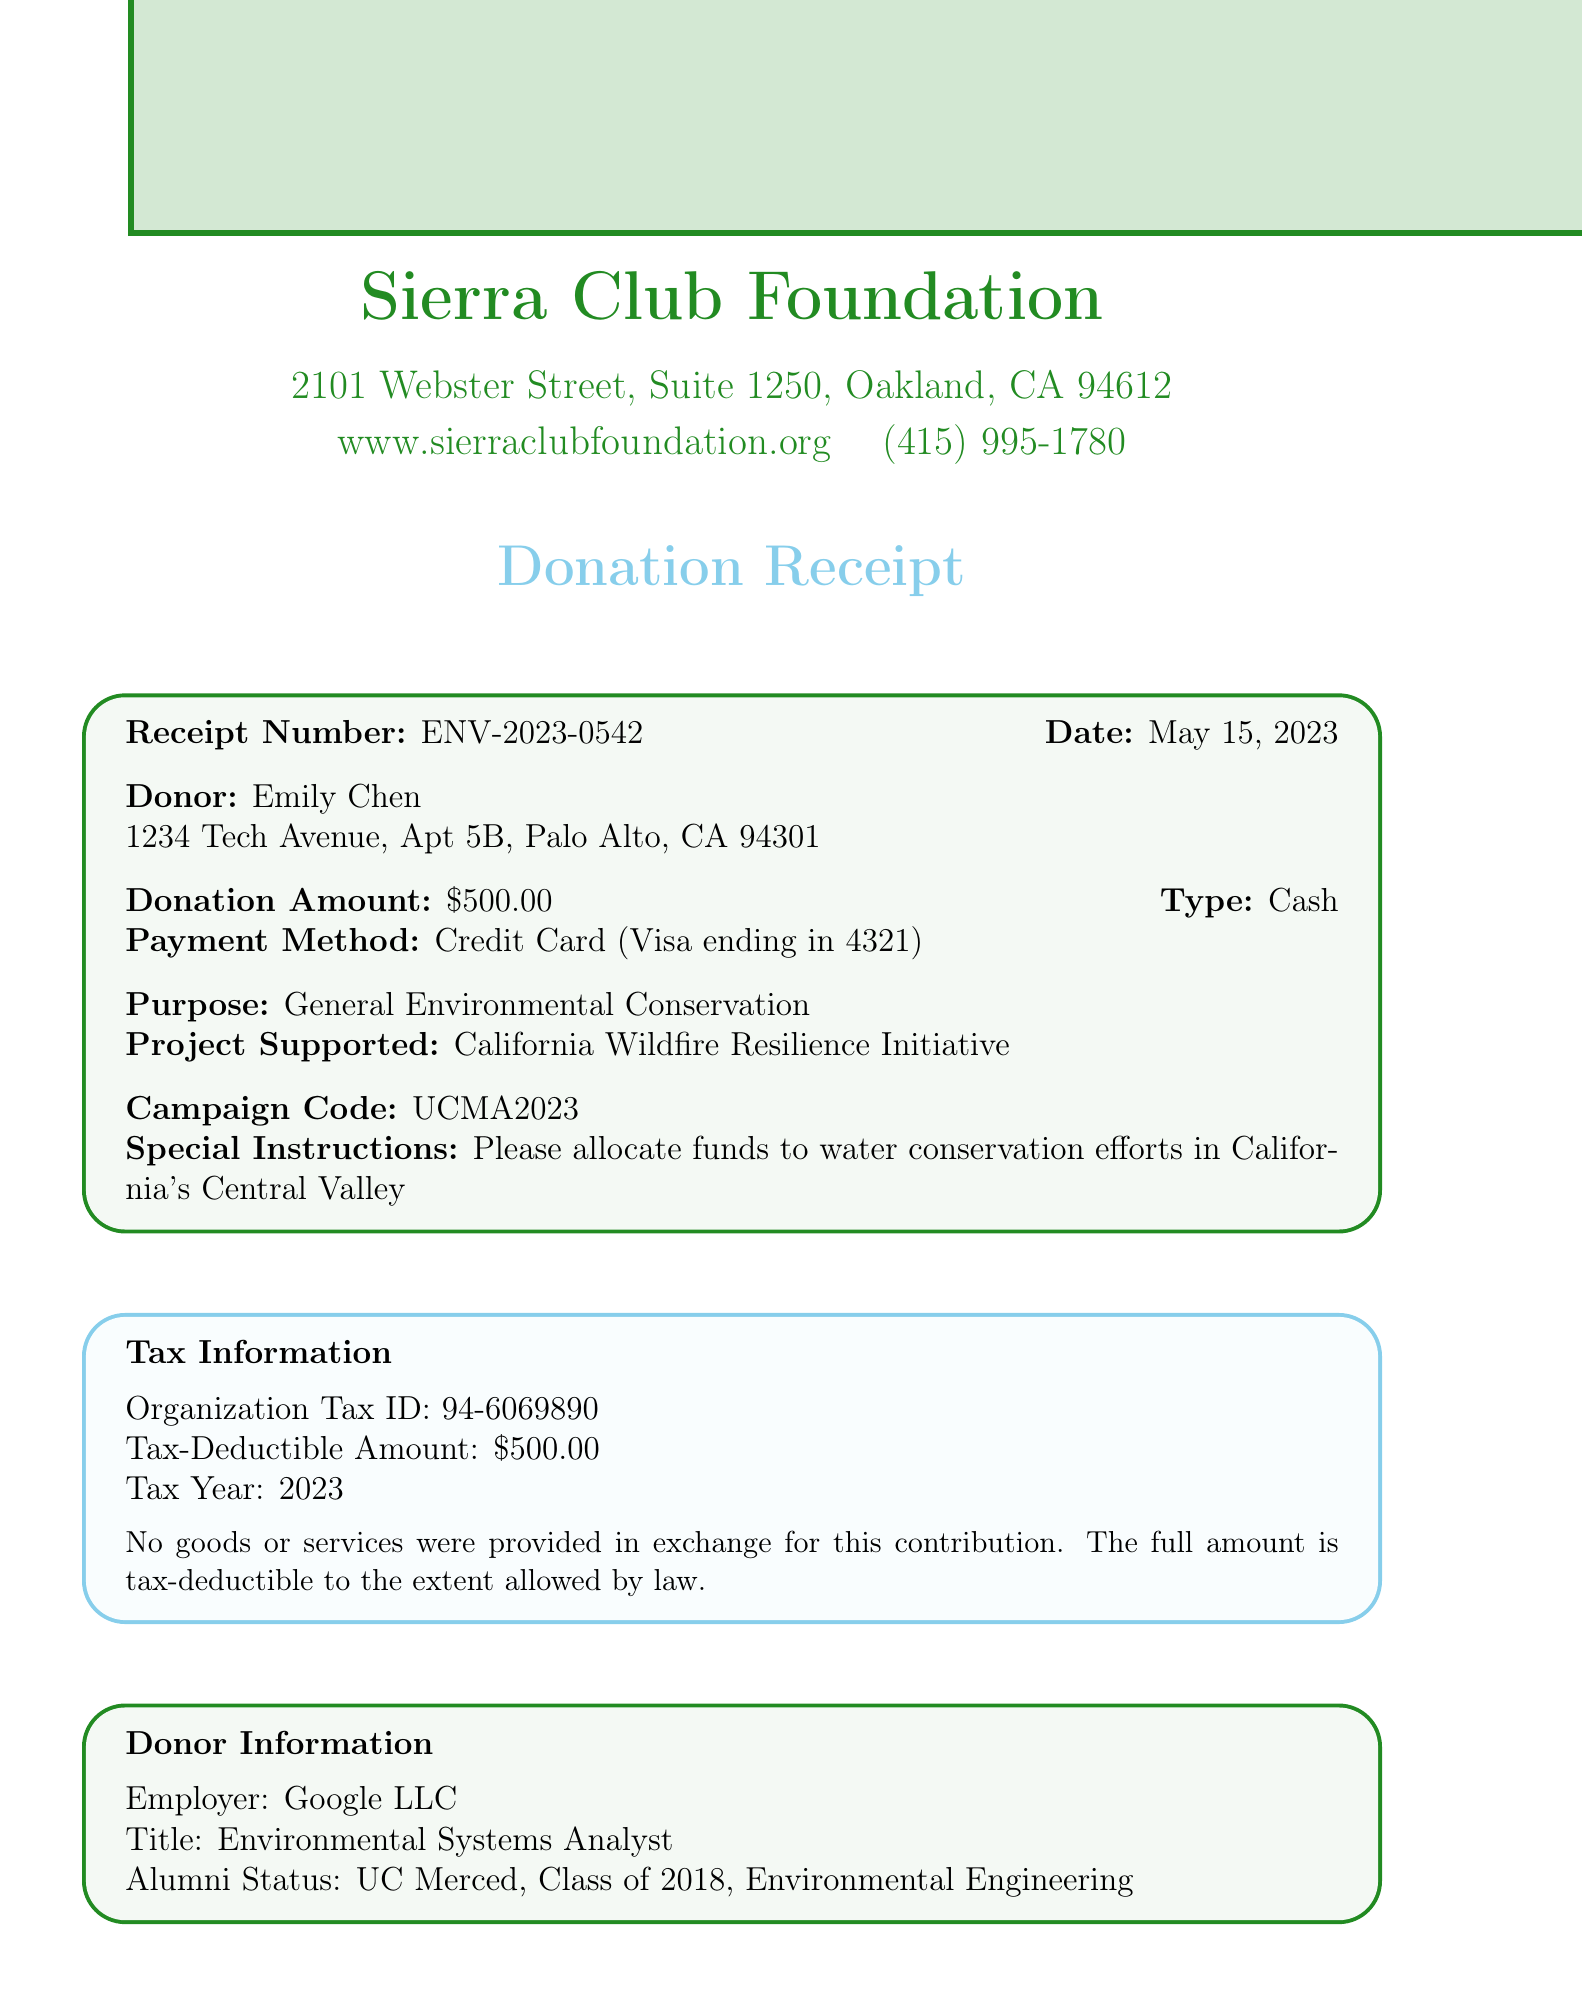What is the receipt number? The receipt number is specified in the document as a unique identifier for this donation.
Answer: ENV-2023-0542 What is the donor's name? The donor's name is clearly stated at the beginning of the receipt.
Answer: Emily Chen What is the donation amount? The document lists the total amount donated by the donor.
Answer: $500.00 What is the purpose of the donation? The purpose of the donation is indicated to specify its intended use.
Answer: General Environmental Conservation What is the tax-deductible amount? The document specifies the amount that can be deducted from taxes.
Answer: $500.00 Who is the donor's employer? The employer of the donor is mentioned in the document to provide additional information about the donor.
Answer: Google LLC What is the campaign code? The campaign code is included in the document for tracking the donation campaign.
Answer: UCMA2023 What project does the donation support? The project supported by this donation is clearly indicated in the document.
Answer: California Wildfire Resilience Initiative What is the donor's title? The title of the donor is provided to highlight their professional role.
Answer: Environmental Systems Analyst How many times is this donation made? The frequency of the donation is specified, indicating whether it is a one-time or recurring donation.
Answer: One-time 